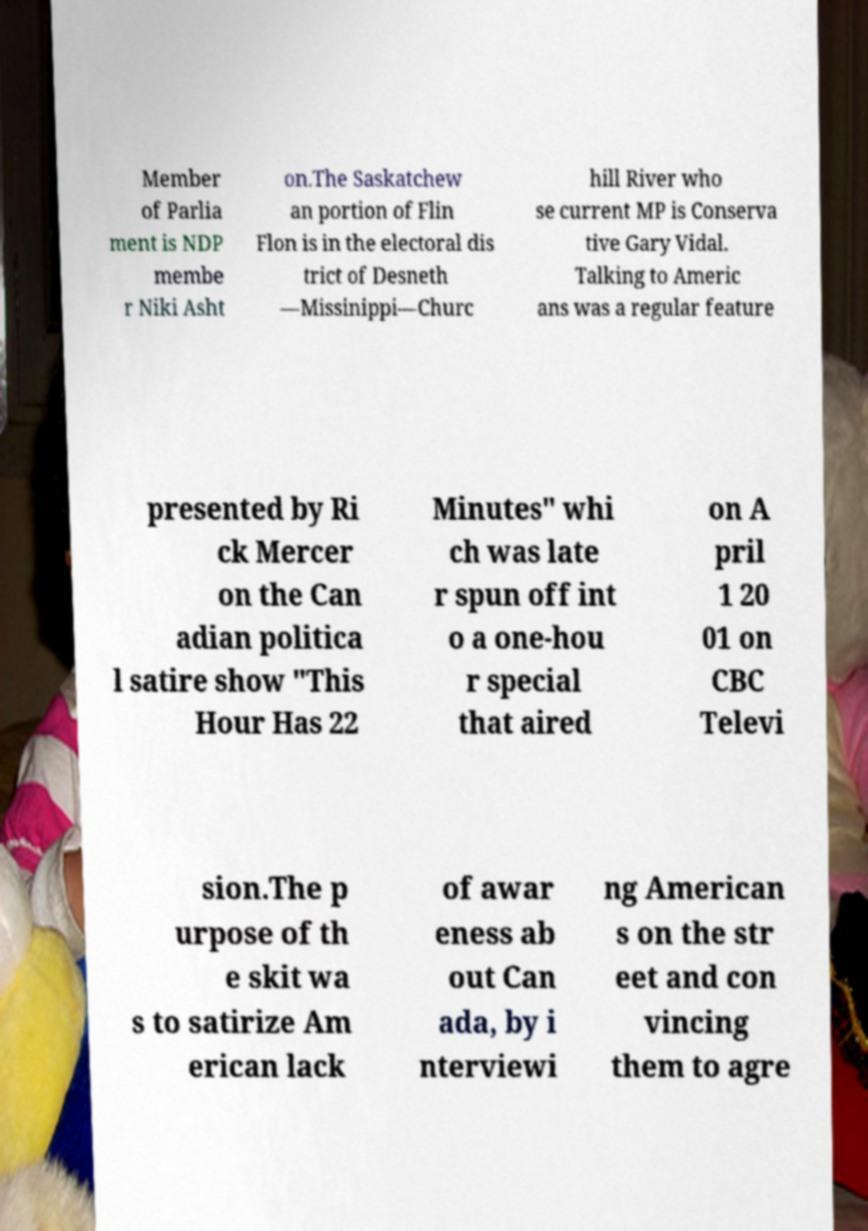Can you read and provide the text displayed in the image?This photo seems to have some interesting text. Can you extract and type it out for me? Member of Parlia ment is NDP membe r Niki Asht on.The Saskatchew an portion of Flin Flon is in the electoral dis trict of Desneth —Missinippi—Churc hill River who se current MP is Conserva tive Gary Vidal. Talking to Americ ans was a regular feature presented by Ri ck Mercer on the Can adian politica l satire show "This Hour Has 22 Minutes" whi ch was late r spun off int o a one-hou r special that aired on A pril 1 20 01 on CBC Televi sion.The p urpose of th e skit wa s to satirize Am erican lack of awar eness ab out Can ada, by i nterviewi ng American s on the str eet and con vincing them to agre 